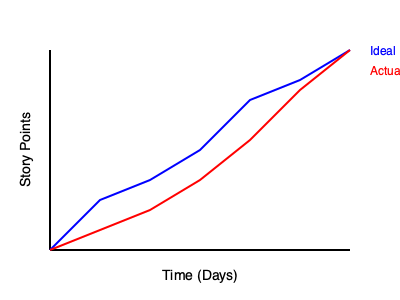As a freelance project manager using entrepreneur's software for workflow management, you're analyzing a burn-down chart for an agile project. The chart shows the ideal burn-down line in blue and the actual burn-down line in red. Based on this chart, what can you conclude about the project's progress? To interpret this burn-down chart, we need to analyze the relationship between the ideal (blue) and actual (red) burn-down lines:

1. Start of the project: Both lines begin at the same point, indicating the initial total story points.

2. Progress over time:
   - The blue line represents the ideal progress, showing a steady, linear decrease in story points.
   - The red line represents the actual progress.

3. Comparing actual vs. ideal:
   - For the first three time periods, the red line is above the blue line. This indicates that the team is completing fewer story points than planned, falling behind schedule.
   - Around the midpoint of the project, the red line intersects and goes below the blue line. This suggests that the team has caught up and is now ahead of schedule.
   - Towards the end of the project, the red line remains below the blue line, indicating that the team is maintaining their lead and potentially finishing early.

4. Slope analysis:
   - The red line's slope becomes steeper in the latter half of the project, showing an increased velocity in completing story points.

5. Endpoint:
   - Both lines converge to zero at the end, suggesting that all planned work is expected to be completed by the project deadline.
Answer: The project started behind schedule but caught up midway and is now ahead of the ideal progress, likely to finish early or on time. 